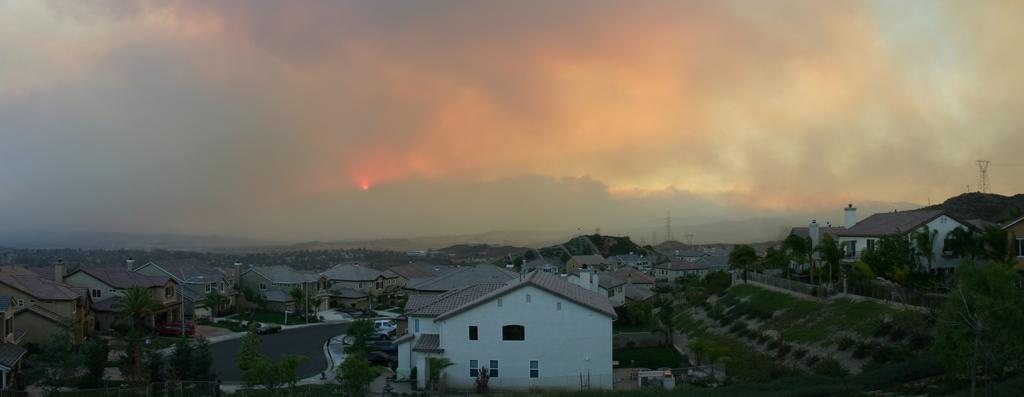Could you give a brief overview of what you see in this image? This is the aerial view image of a town with many homes and buildings all over with road and either side with trees in front of the homes and above its sky with clouds. 